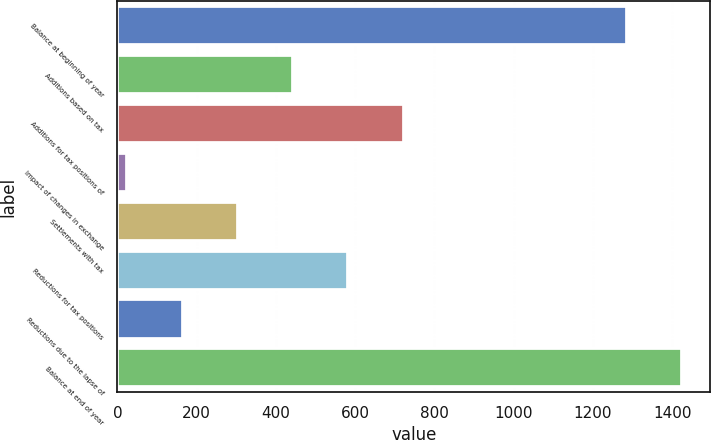Convert chart. <chart><loc_0><loc_0><loc_500><loc_500><bar_chart><fcel>Balance at beginning of year<fcel>Additions based on tax<fcel>Additions for tax positions of<fcel>Impact of changes in exchange<fcel>Settlements with tax<fcel>Reductions for tax positions<fcel>Reductions due to the lapse of<fcel>Balance at end of year<nl><fcel>1285<fcel>443.2<fcel>722<fcel>25<fcel>303.8<fcel>582.6<fcel>164.4<fcel>1424.4<nl></chart> 